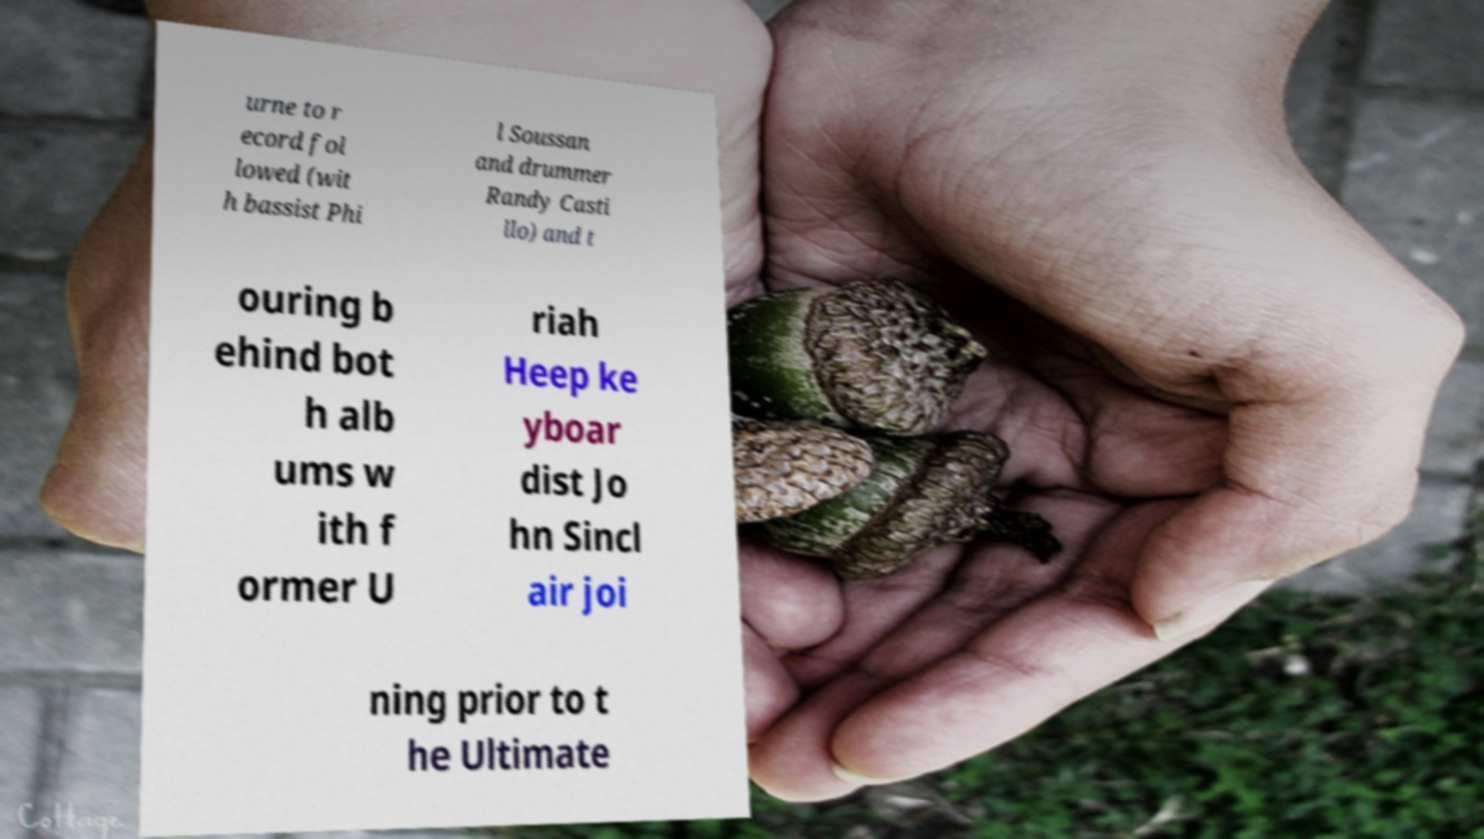Please identify and transcribe the text found in this image. urne to r ecord fol lowed (wit h bassist Phi l Soussan and drummer Randy Casti llo) and t ouring b ehind bot h alb ums w ith f ormer U riah Heep ke yboar dist Jo hn Sincl air joi ning prior to t he Ultimate 